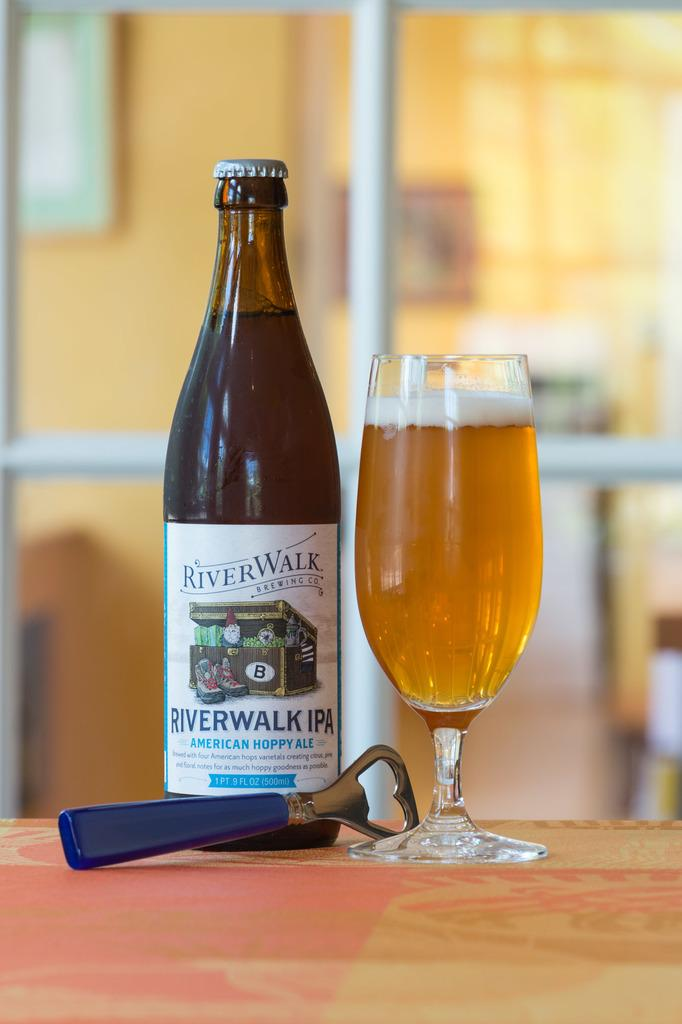<image>
Render a clear and concise summary of the photo. A Riverwalk branded Ale poured into a glass. 